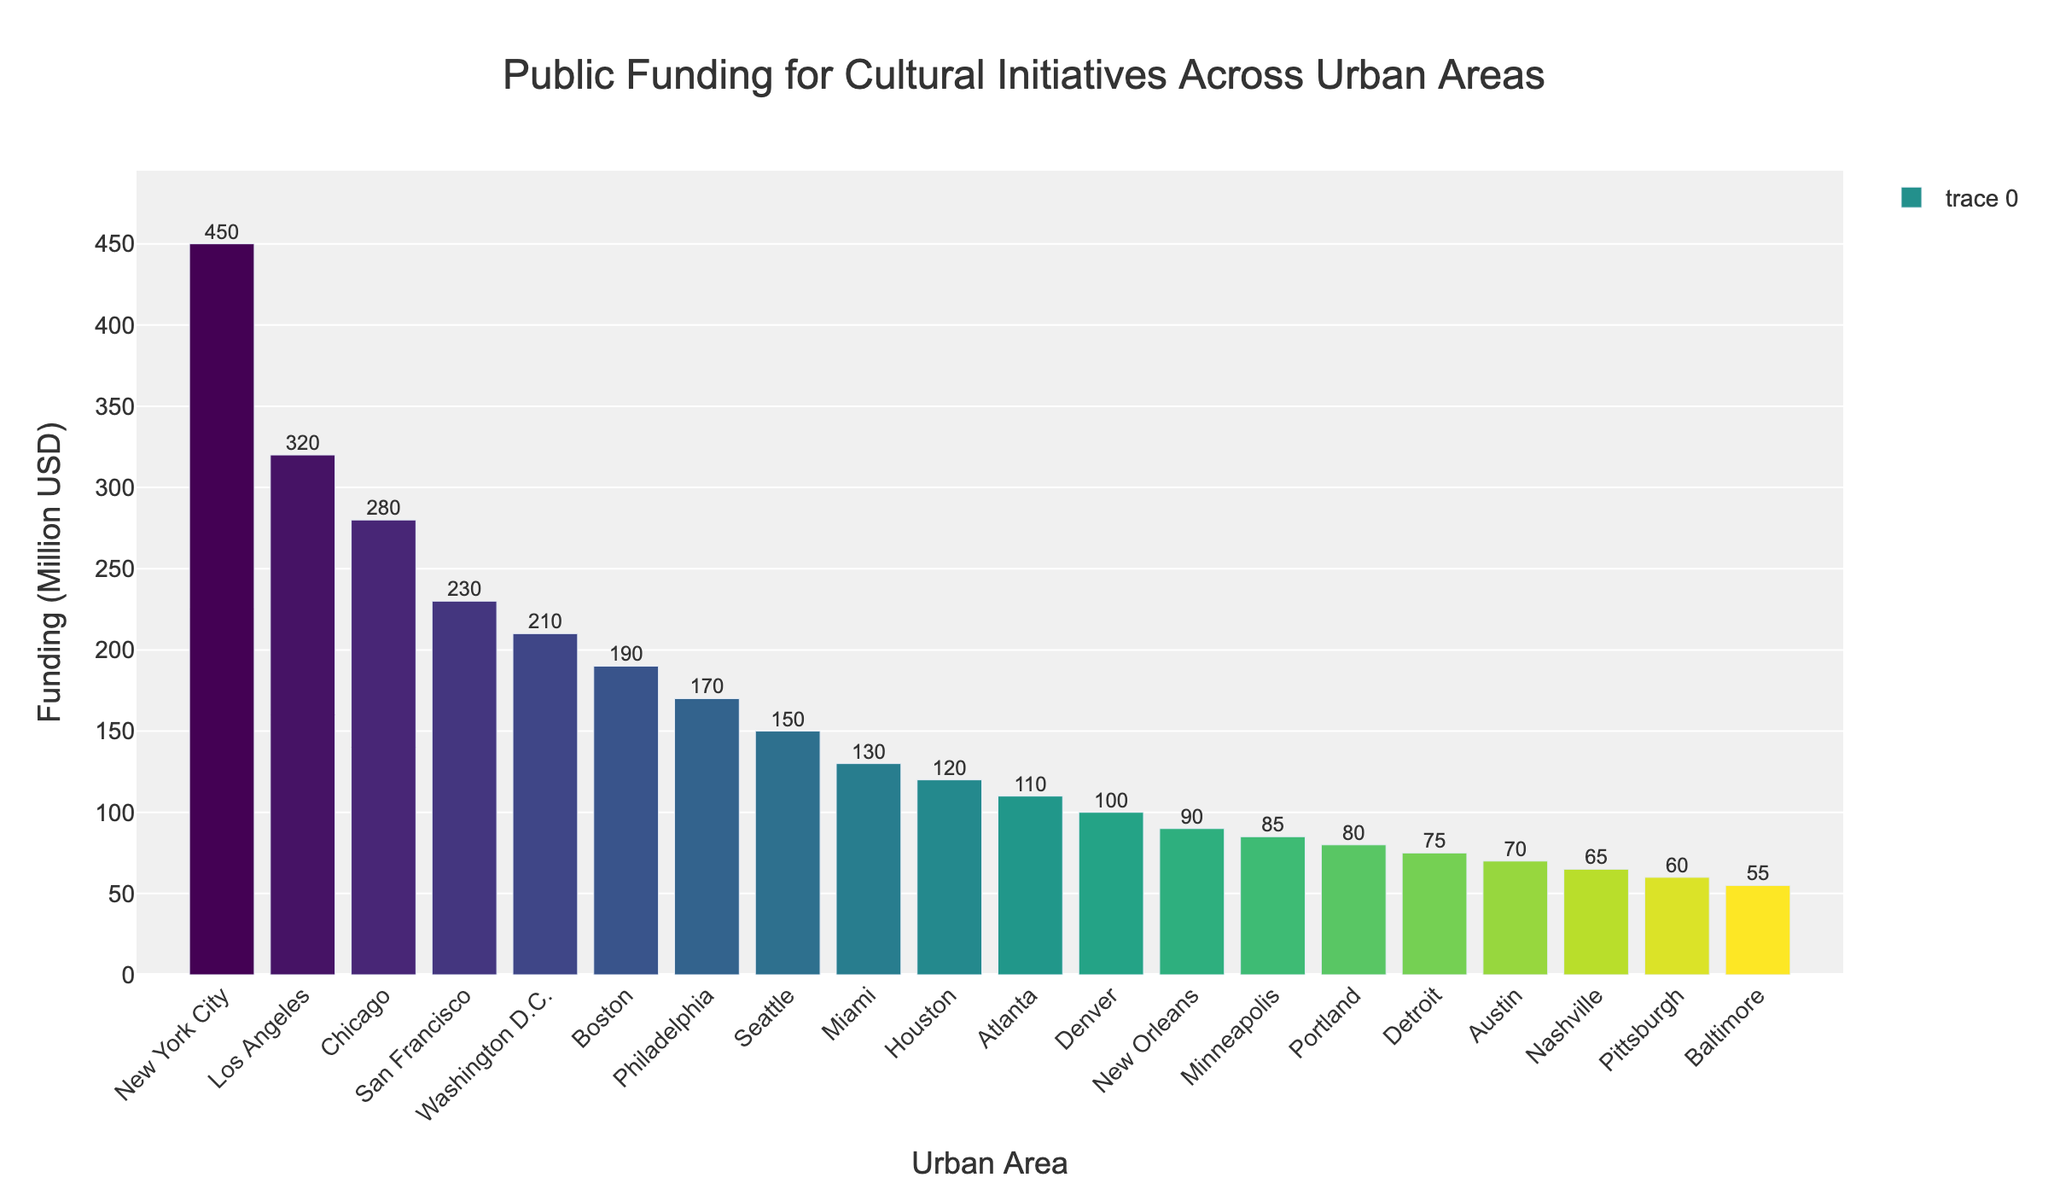Which urban area received the highest public funding for cultural initiatives? From the bar chart, the tallest bar indicates the urban area with the highest funding. The tallest bar is labeled "New York City" with $450 million.
Answer: New York City Which urban area received the lowest public funding for cultural initiatives? The shortest bar illustrates the urban area with the lowest funding. The shortest bar is labeled "Baltimore" with $55 million.
Answer: Baltimore How much more funding did New York City receive compared to Los Angeles? New York City received $450 million, and Los Angeles received $320 million. The difference is calculated as $450 million - $320 million = $130 million.
Answer: $130 million What is the combined public funding for cultural initiatives for San Francisco and Washington D.C.? San Francisco received $230 million, and Washington D.C. received $210 million. The combined funding is $230 million + $210 million = $440 million.
Answer: $440 million Among the cities listed, which city is closest in funding to $100 million? Denver is labeled with $100 million, which exactly matches the sought value.
Answer: Denver Is the funding for Philadelphia higher or lower than that for Seattle? Philadelphia received $170 million, and Seattle received $150 million. Comparing these values, Philadelphia's funding is higher.
Answer: Higher What is the difference in funding between the city with the highest funding and the city with the median funding amount? The funding amounts are sorted in descending order. The median city (middle value) in a list of 20 cities is the 10th city, which is Houston with $120 million. New York City, the highest, has $450 million. The difference is $450 million - $120 million = $330 million.
Answer: $330 million How many urban areas have received more than $200 million in funding? Urban areas with more than $200 million are New York City, Los Angeles, Chicago, San Francisco, and Washington D.C. There are 5 such areas.
Answer: 5 What is the average funding of the top three urban areas? The top three urban areas are New York City ($450 million), Los Angeles ($320 million), and Chicago ($280 million). The average is calculated as ($450 million + $320 million + $280 million) / 3 = $1,050 million / 3 ≈ $350 million.
Answer: $350 million Which city has just $10 million less funding than the second-highest funded city? The second-highest funded city is Los Angeles with $320 million. Chicago has $280 million, which is more than $10 million less, but San Francisco has $230 million, exactly $10 million less.
Answer: San Francisco 